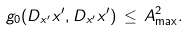Convert formula to latex. <formula><loc_0><loc_0><loc_500><loc_500>g _ { 0 } ( D _ { x ^ { \prime } } x ^ { \prime } , D _ { x ^ { \prime } } x ^ { \prime } ) \, \leq \, A ^ { 2 } _ { \max } .</formula> 